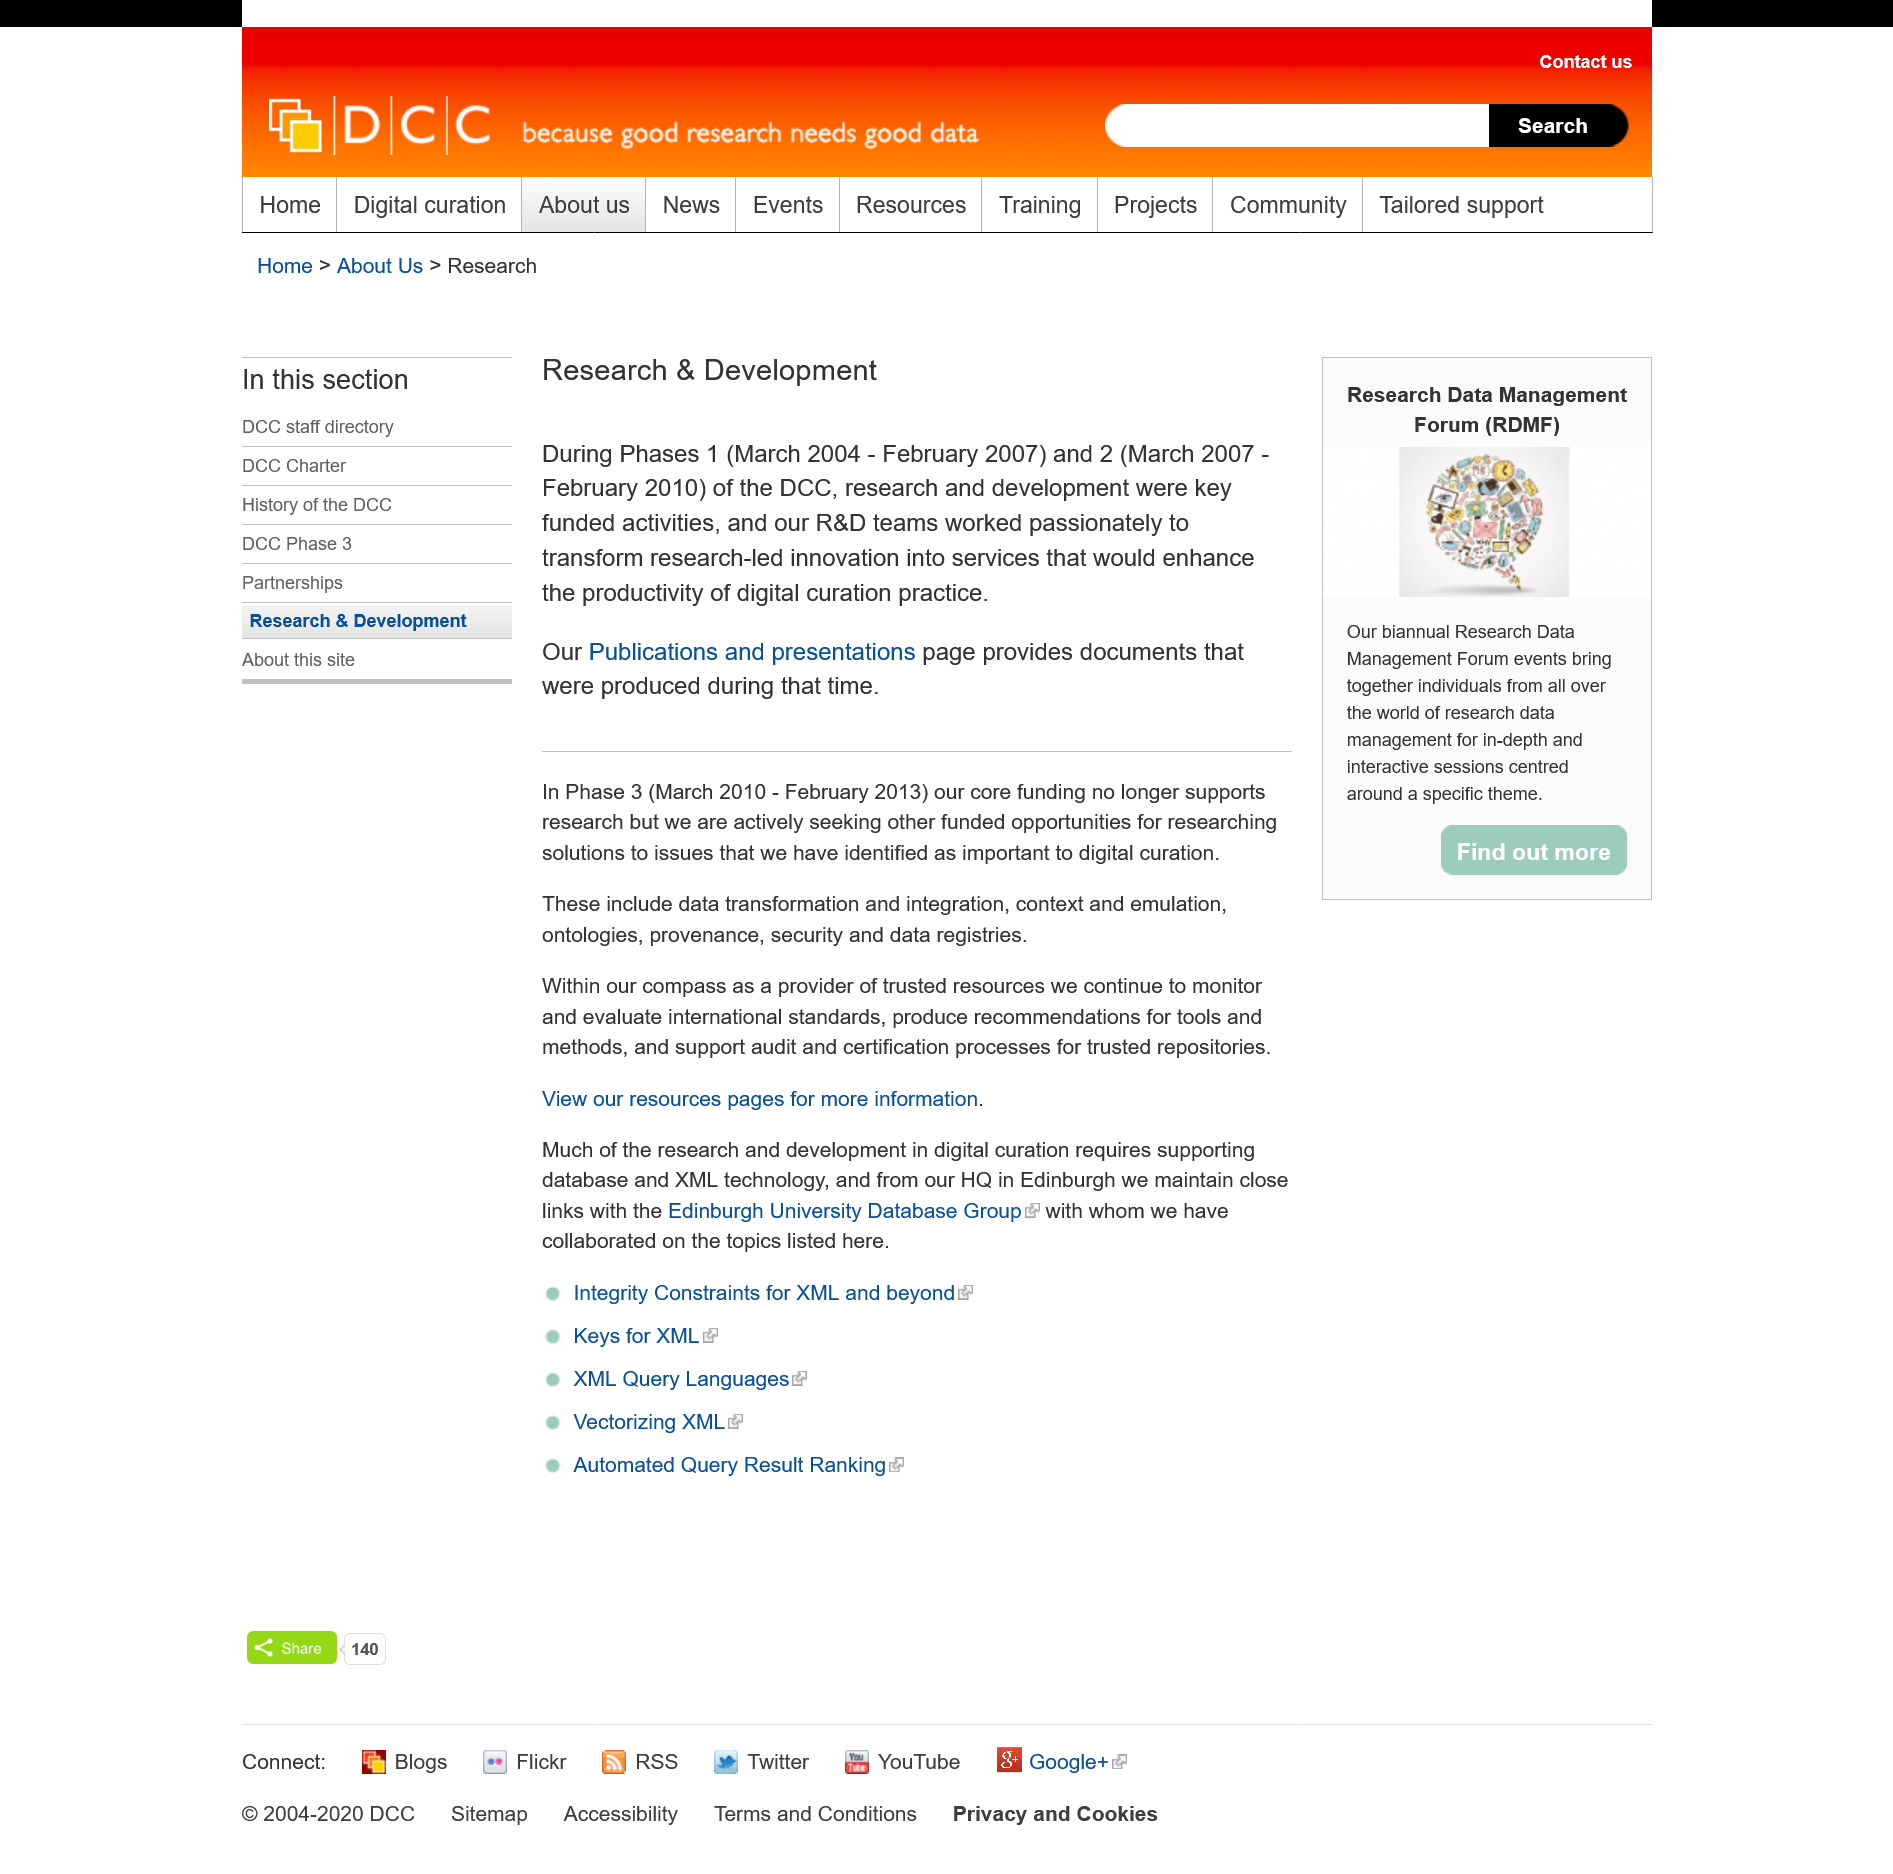Give some essential details in this illustration. The phase 2 started on March 2007. Phase one of the COVID-19 pandemic ended in February 2007. Phase one commenced in March 2004. 